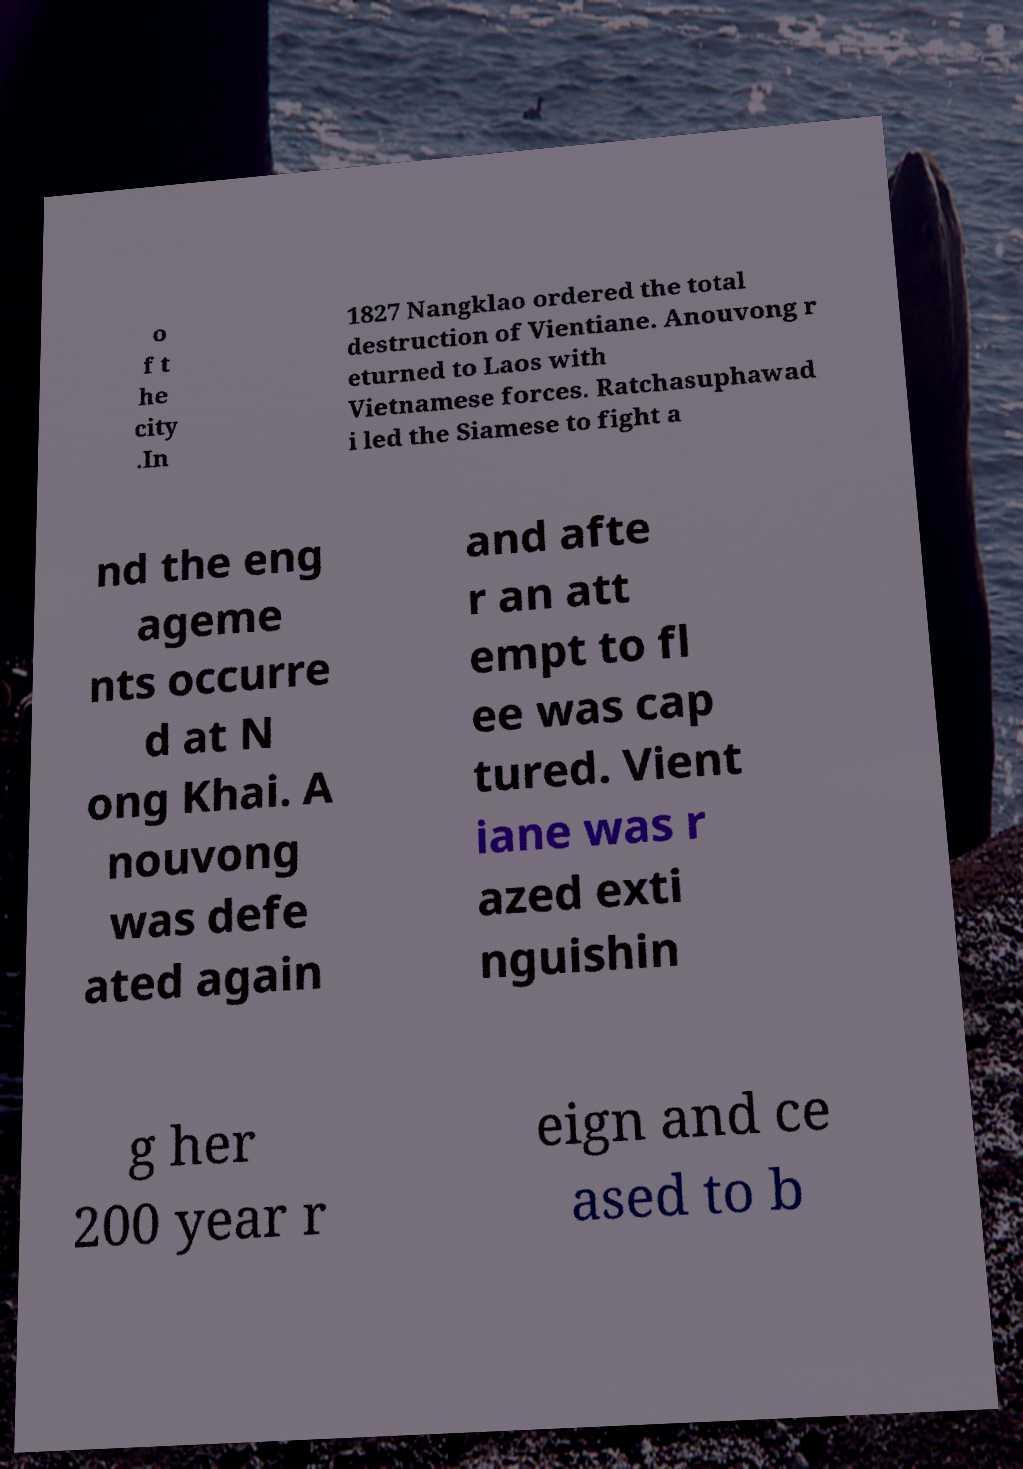Could you assist in decoding the text presented in this image and type it out clearly? o f t he city .In 1827 Nangklao ordered the total destruction of Vientiane. Anouvong r eturned to Laos with Vietnamese forces. Ratchasuphawad i led the Siamese to fight a nd the eng ageme nts occurre d at N ong Khai. A nouvong was defe ated again and afte r an att empt to fl ee was cap tured. Vient iane was r azed exti nguishin g her 200 year r eign and ce ased to b 